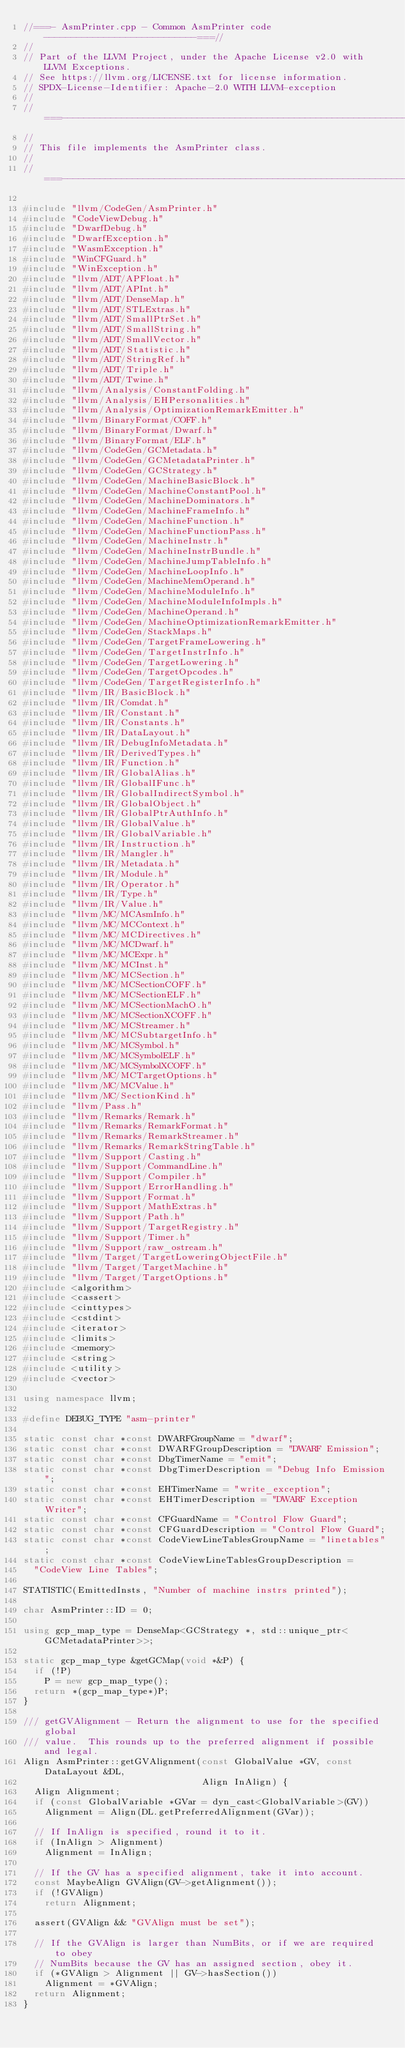<code> <loc_0><loc_0><loc_500><loc_500><_C++_>//===- AsmPrinter.cpp - Common AsmPrinter code ----------------------------===//
//
// Part of the LLVM Project, under the Apache License v2.0 with LLVM Exceptions.
// See https://llvm.org/LICENSE.txt for license information.
// SPDX-License-Identifier: Apache-2.0 WITH LLVM-exception
//
//===----------------------------------------------------------------------===//
//
// This file implements the AsmPrinter class.
//
//===----------------------------------------------------------------------===//

#include "llvm/CodeGen/AsmPrinter.h"
#include "CodeViewDebug.h"
#include "DwarfDebug.h"
#include "DwarfException.h"
#include "WasmException.h"
#include "WinCFGuard.h"
#include "WinException.h"
#include "llvm/ADT/APFloat.h"
#include "llvm/ADT/APInt.h"
#include "llvm/ADT/DenseMap.h"
#include "llvm/ADT/STLExtras.h"
#include "llvm/ADT/SmallPtrSet.h"
#include "llvm/ADT/SmallString.h"
#include "llvm/ADT/SmallVector.h"
#include "llvm/ADT/Statistic.h"
#include "llvm/ADT/StringRef.h"
#include "llvm/ADT/Triple.h"
#include "llvm/ADT/Twine.h"
#include "llvm/Analysis/ConstantFolding.h"
#include "llvm/Analysis/EHPersonalities.h"
#include "llvm/Analysis/OptimizationRemarkEmitter.h"
#include "llvm/BinaryFormat/COFF.h"
#include "llvm/BinaryFormat/Dwarf.h"
#include "llvm/BinaryFormat/ELF.h"
#include "llvm/CodeGen/GCMetadata.h"
#include "llvm/CodeGen/GCMetadataPrinter.h"
#include "llvm/CodeGen/GCStrategy.h"
#include "llvm/CodeGen/MachineBasicBlock.h"
#include "llvm/CodeGen/MachineConstantPool.h"
#include "llvm/CodeGen/MachineDominators.h"
#include "llvm/CodeGen/MachineFrameInfo.h"
#include "llvm/CodeGen/MachineFunction.h"
#include "llvm/CodeGen/MachineFunctionPass.h"
#include "llvm/CodeGen/MachineInstr.h"
#include "llvm/CodeGen/MachineInstrBundle.h"
#include "llvm/CodeGen/MachineJumpTableInfo.h"
#include "llvm/CodeGen/MachineLoopInfo.h"
#include "llvm/CodeGen/MachineMemOperand.h"
#include "llvm/CodeGen/MachineModuleInfo.h"
#include "llvm/CodeGen/MachineModuleInfoImpls.h"
#include "llvm/CodeGen/MachineOperand.h"
#include "llvm/CodeGen/MachineOptimizationRemarkEmitter.h"
#include "llvm/CodeGen/StackMaps.h"
#include "llvm/CodeGen/TargetFrameLowering.h"
#include "llvm/CodeGen/TargetInstrInfo.h"
#include "llvm/CodeGen/TargetLowering.h"
#include "llvm/CodeGen/TargetOpcodes.h"
#include "llvm/CodeGen/TargetRegisterInfo.h"
#include "llvm/IR/BasicBlock.h"
#include "llvm/IR/Comdat.h"
#include "llvm/IR/Constant.h"
#include "llvm/IR/Constants.h"
#include "llvm/IR/DataLayout.h"
#include "llvm/IR/DebugInfoMetadata.h"
#include "llvm/IR/DerivedTypes.h"
#include "llvm/IR/Function.h"
#include "llvm/IR/GlobalAlias.h"
#include "llvm/IR/GlobalIFunc.h"
#include "llvm/IR/GlobalIndirectSymbol.h"
#include "llvm/IR/GlobalObject.h"
#include "llvm/IR/GlobalPtrAuthInfo.h"
#include "llvm/IR/GlobalValue.h"
#include "llvm/IR/GlobalVariable.h"
#include "llvm/IR/Instruction.h"
#include "llvm/IR/Mangler.h"
#include "llvm/IR/Metadata.h"
#include "llvm/IR/Module.h"
#include "llvm/IR/Operator.h"
#include "llvm/IR/Type.h"
#include "llvm/IR/Value.h"
#include "llvm/MC/MCAsmInfo.h"
#include "llvm/MC/MCContext.h"
#include "llvm/MC/MCDirectives.h"
#include "llvm/MC/MCDwarf.h"
#include "llvm/MC/MCExpr.h"
#include "llvm/MC/MCInst.h"
#include "llvm/MC/MCSection.h"
#include "llvm/MC/MCSectionCOFF.h"
#include "llvm/MC/MCSectionELF.h"
#include "llvm/MC/MCSectionMachO.h"
#include "llvm/MC/MCSectionXCOFF.h"
#include "llvm/MC/MCStreamer.h"
#include "llvm/MC/MCSubtargetInfo.h"
#include "llvm/MC/MCSymbol.h"
#include "llvm/MC/MCSymbolELF.h"
#include "llvm/MC/MCSymbolXCOFF.h"
#include "llvm/MC/MCTargetOptions.h"
#include "llvm/MC/MCValue.h"
#include "llvm/MC/SectionKind.h"
#include "llvm/Pass.h"
#include "llvm/Remarks/Remark.h"
#include "llvm/Remarks/RemarkFormat.h"
#include "llvm/Remarks/RemarkStreamer.h"
#include "llvm/Remarks/RemarkStringTable.h"
#include "llvm/Support/Casting.h"
#include "llvm/Support/CommandLine.h"
#include "llvm/Support/Compiler.h"
#include "llvm/Support/ErrorHandling.h"
#include "llvm/Support/Format.h"
#include "llvm/Support/MathExtras.h"
#include "llvm/Support/Path.h"
#include "llvm/Support/TargetRegistry.h"
#include "llvm/Support/Timer.h"
#include "llvm/Support/raw_ostream.h"
#include "llvm/Target/TargetLoweringObjectFile.h"
#include "llvm/Target/TargetMachine.h"
#include "llvm/Target/TargetOptions.h"
#include <algorithm>
#include <cassert>
#include <cinttypes>
#include <cstdint>
#include <iterator>
#include <limits>
#include <memory>
#include <string>
#include <utility>
#include <vector>

using namespace llvm;

#define DEBUG_TYPE "asm-printer"

static const char *const DWARFGroupName = "dwarf";
static const char *const DWARFGroupDescription = "DWARF Emission";
static const char *const DbgTimerName = "emit";
static const char *const DbgTimerDescription = "Debug Info Emission";
static const char *const EHTimerName = "write_exception";
static const char *const EHTimerDescription = "DWARF Exception Writer";
static const char *const CFGuardName = "Control Flow Guard";
static const char *const CFGuardDescription = "Control Flow Guard";
static const char *const CodeViewLineTablesGroupName = "linetables";
static const char *const CodeViewLineTablesGroupDescription =
  "CodeView Line Tables";

STATISTIC(EmittedInsts, "Number of machine instrs printed");

char AsmPrinter::ID = 0;

using gcp_map_type = DenseMap<GCStrategy *, std::unique_ptr<GCMetadataPrinter>>;

static gcp_map_type &getGCMap(void *&P) {
  if (!P)
    P = new gcp_map_type();
  return *(gcp_map_type*)P;
}

/// getGVAlignment - Return the alignment to use for the specified global
/// value.  This rounds up to the preferred alignment if possible and legal.
Align AsmPrinter::getGVAlignment(const GlobalValue *GV, const DataLayout &DL,
                                 Align InAlign) {
  Align Alignment;
  if (const GlobalVariable *GVar = dyn_cast<GlobalVariable>(GV))
    Alignment = Align(DL.getPreferredAlignment(GVar));

  // If InAlign is specified, round it to it.
  if (InAlign > Alignment)
    Alignment = InAlign;

  // If the GV has a specified alignment, take it into account.
  const MaybeAlign GVAlign(GV->getAlignment());
  if (!GVAlign)
    return Alignment;

  assert(GVAlign && "GVAlign must be set");

  // If the GVAlign is larger than NumBits, or if we are required to obey
  // NumBits because the GV has an assigned section, obey it.
  if (*GVAlign > Alignment || GV->hasSection())
    Alignment = *GVAlign;
  return Alignment;
}
</code> 